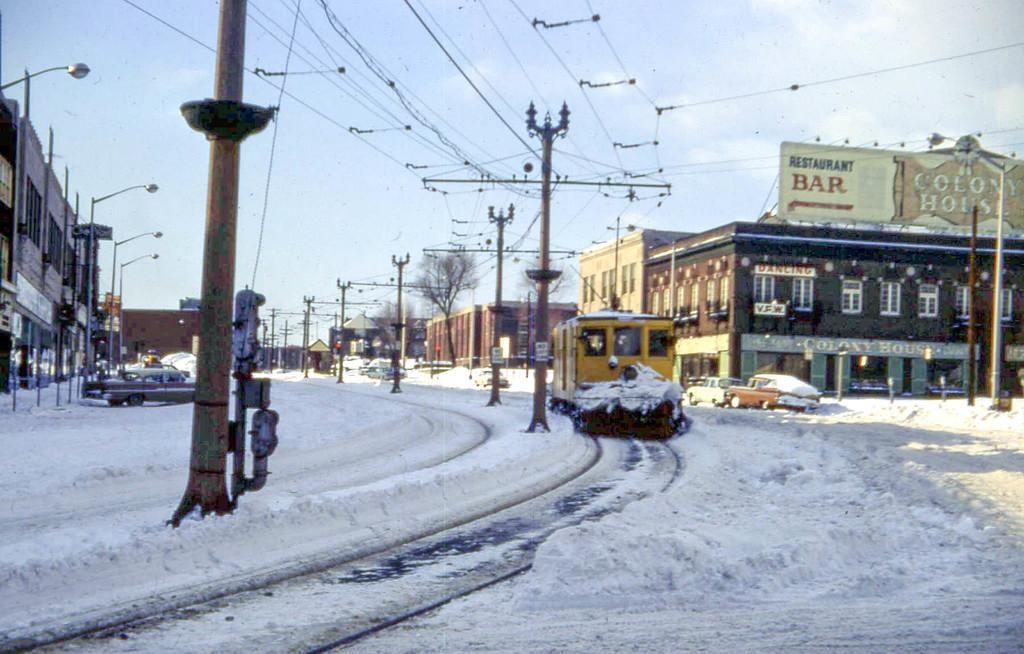Provide a one-sentence caption for the provided image. A bar sign on top of a building is visible from the snowy street. 